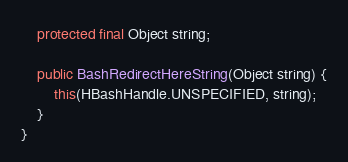<code> <loc_0><loc_0><loc_500><loc_500><_Java_>	protected final Object string;

	public BashRedirectHereString(Object string) {
		this(HBashHandle.UNSPECIFIED, string);
	}
}
</code> 